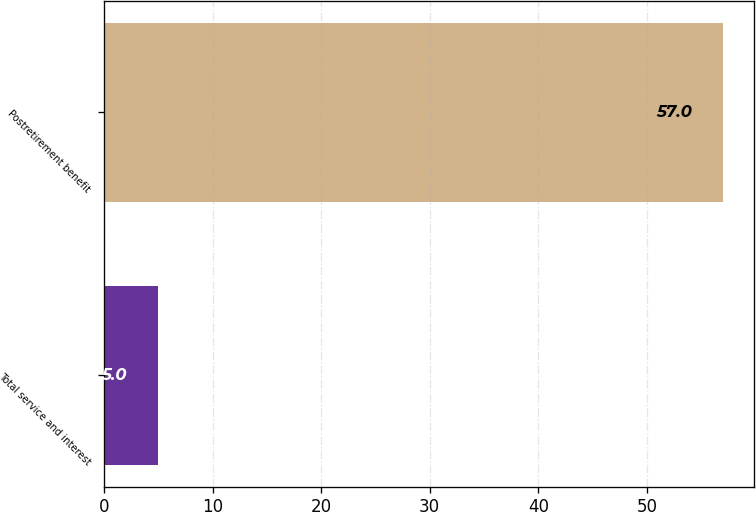<chart> <loc_0><loc_0><loc_500><loc_500><bar_chart><fcel>Total service and interest<fcel>Postretirement benefit<nl><fcel>5<fcel>57<nl></chart> 